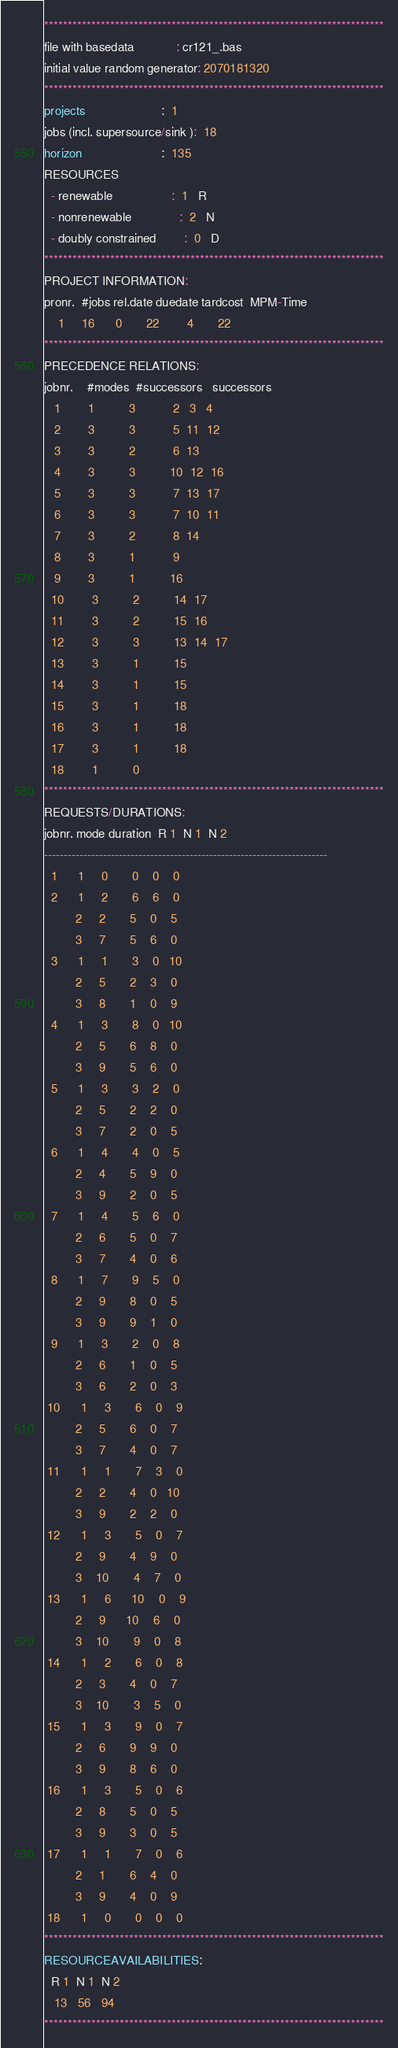Convert code to text. <code><loc_0><loc_0><loc_500><loc_500><_ObjectiveC_>************************************************************************
file with basedata            : cr121_.bas
initial value random generator: 2070181320
************************************************************************
projects                      :  1
jobs (incl. supersource/sink ):  18
horizon                       :  135
RESOURCES
  - renewable                 :  1   R
  - nonrenewable              :  2   N
  - doubly constrained        :  0   D
************************************************************************
PROJECT INFORMATION:
pronr.  #jobs rel.date duedate tardcost  MPM-Time
    1     16      0       22        4       22
************************************************************************
PRECEDENCE RELATIONS:
jobnr.    #modes  #successors   successors
   1        1          3           2   3   4
   2        3          3           5  11  12
   3        3          2           6  13
   4        3          3          10  12  16
   5        3          3           7  13  17
   6        3          3           7  10  11
   7        3          2           8  14
   8        3          1           9
   9        3          1          16
  10        3          2          14  17
  11        3          2          15  16
  12        3          3          13  14  17
  13        3          1          15
  14        3          1          15
  15        3          1          18
  16        3          1          18
  17        3          1          18
  18        1          0        
************************************************************************
REQUESTS/DURATIONS:
jobnr. mode duration  R 1  N 1  N 2
------------------------------------------------------------------------
  1      1     0       0    0    0
  2      1     2       6    6    0
         2     2       5    0    5
         3     7       5    6    0
  3      1     1       3    0   10
         2     5       2    3    0
         3     8       1    0    9
  4      1     3       8    0   10
         2     5       6    8    0
         3     9       5    6    0
  5      1     3       3    2    0
         2     5       2    2    0
         3     7       2    0    5
  6      1     4       4    0    5
         2     4       5    9    0
         3     9       2    0    5
  7      1     4       5    6    0
         2     6       5    0    7
         3     7       4    0    6
  8      1     7       9    5    0
         2     9       8    0    5
         3     9       9    1    0
  9      1     3       2    0    8
         2     6       1    0    5
         3     6       2    0    3
 10      1     3       6    0    9
         2     5       6    0    7
         3     7       4    0    7
 11      1     1       7    3    0
         2     2       4    0   10
         3     9       2    2    0
 12      1     3       5    0    7
         2     9       4    9    0
         3    10       4    7    0
 13      1     6      10    0    9
         2     9      10    6    0
         3    10       9    0    8
 14      1     2       6    0    8
         2     3       4    0    7
         3    10       3    5    0
 15      1     3       9    0    7
         2     6       9    9    0
         3     9       8    6    0
 16      1     3       5    0    6
         2     8       5    0    5
         3     9       3    0    5
 17      1     1       7    0    6
         2     1       6    4    0
         3     9       4    0    9
 18      1     0       0    0    0
************************************************************************
RESOURCEAVAILABILITIES:
  R 1  N 1  N 2
   13   56   94
************************************************************************
</code> 